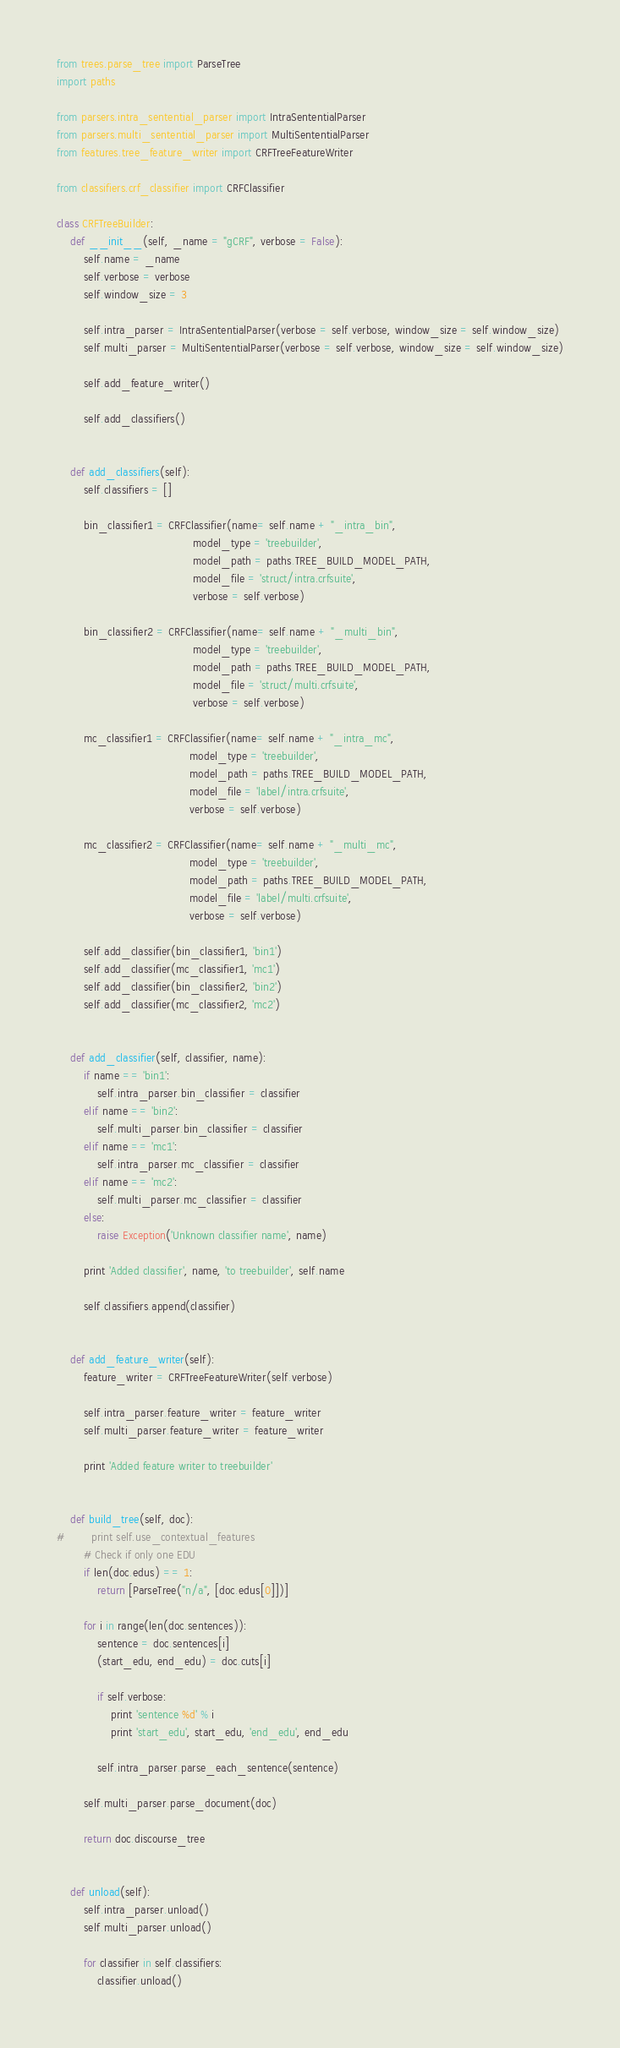Convert code to text. <code><loc_0><loc_0><loc_500><loc_500><_Python_>
from trees.parse_tree import ParseTree
import paths

from parsers.intra_sentential_parser import IntraSententialParser
from parsers.multi_sentential_parser import MultiSententialParser
from features.tree_feature_writer import CRFTreeFeatureWriter

from classifiers.crf_classifier import CRFClassifier

class CRFTreeBuilder:
    def __init__(self, _name = "gCRF", verbose = False):
        self.name = _name
        self.verbose = verbose
        self.window_size = 3
        
        self.intra_parser = IntraSententialParser(verbose = self.verbose, window_size = self.window_size)
        self.multi_parser = MultiSententialParser(verbose = self.verbose, window_size = self.window_size)
        
        self.add_feature_writer()
        
        self.add_classifiers()
    
    
    def add_classifiers(self):
        self.classifiers = []
        
        bin_classifier1 = CRFClassifier(name= self.name + "_intra_bin",
                                        model_type = 'treebuilder',
                                        model_path = paths.TREE_BUILD_MODEL_PATH,
                                        model_file = 'struct/intra.crfsuite',
                                        verbose = self.verbose)
            
        bin_classifier2 = CRFClassifier(name= self.name + "_multi_bin",
                                        model_type = 'treebuilder',
                                        model_path = paths.TREE_BUILD_MODEL_PATH,
                                        model_file = 'struct/multi.crfsuite',
                                        verbose = self.verbose)
        
        mc_classifier1 = CRFClassifier(name= self.name + "_intra_mc",
                                       model_type = 'treebuilder',
                                       model_path = paths.TREE_BUILD_MODEL_PATH,
                                       model_file = 'label/intra.crfsuite',
                                       verbose = self.verbose)
        
        mc_classifier2 = CRFClassifier(name= self.name + "_multi_mc",
                                       model_type = 'treebuilder',
                                       model_path = paths.TREE_BUILD_MODEL_PATH,
                                       model_file = 'label/multi.crfsuite',
                                       verbose = self.verbose)
        
        self.add_classifier(bin_classifier1, 'bin1')
        self.add_classifier(mc_classifier1, 'mc1')
        self.add_classifier(bin_classifier2, 'bin2')
        self.add_classifier(mc_classifier2, 'mc2')
        

    def add_classifier(self, classifier, name):
        if name == 'bin1':
            self.intra_parser.bin_classifier = classifier
        elif name == 'bin2':
            self.multi_parser.bin_classifier = classifier
        elif name == 'mc1':
            self.intra_parser.mc_classifier = classifier
        elif name == 'mc2':
            self.multi_parser.mc_classifier = classifier
        else:
            raise Exception('Unknown classifier name', name)
        
        print 'Added classifier', name, 'to treebuilder', self.name
        
        self.classifiers.append(classifier)
        
        
    def add_feature_writer(self):
        feature_writer = CRFTreeFeatureWriter(self.verbose)
        
        self.intra_parser.feature_writer = feature_writer
        self.multi_parser.feature_writer = feature_writer
        
        print 'Added feature writer to treebuilder'
        
        
    def build_tree(self, doc):
#        print self.use_contextual_features 
        # Check if only one EDU
        if len(doc.edus) == 1:
            return [ParseTree("n/a", [doc.edus[0]])]
        
        for i in range(len(doc.sentences)):
            sentence = doc.sentences[i]
            (start_edu, end_edu) = doc.cuts[i]
            
            if self.verbose:
                print 'sentence %d' % i
                print 'start_edu', start_edu, 'end_edu', end_edu
            
            self.intra_parser.parse_each_sentence(sentence)

        self.multi_parser.parse_document(doc)
    
        return doc.discourse_tree

    
    def unload(self):
        self.intra_parser.unload()
        self.multi_parser.unload()
        
        for classifier in self.classifiers:
            classifier.unload()</code> 